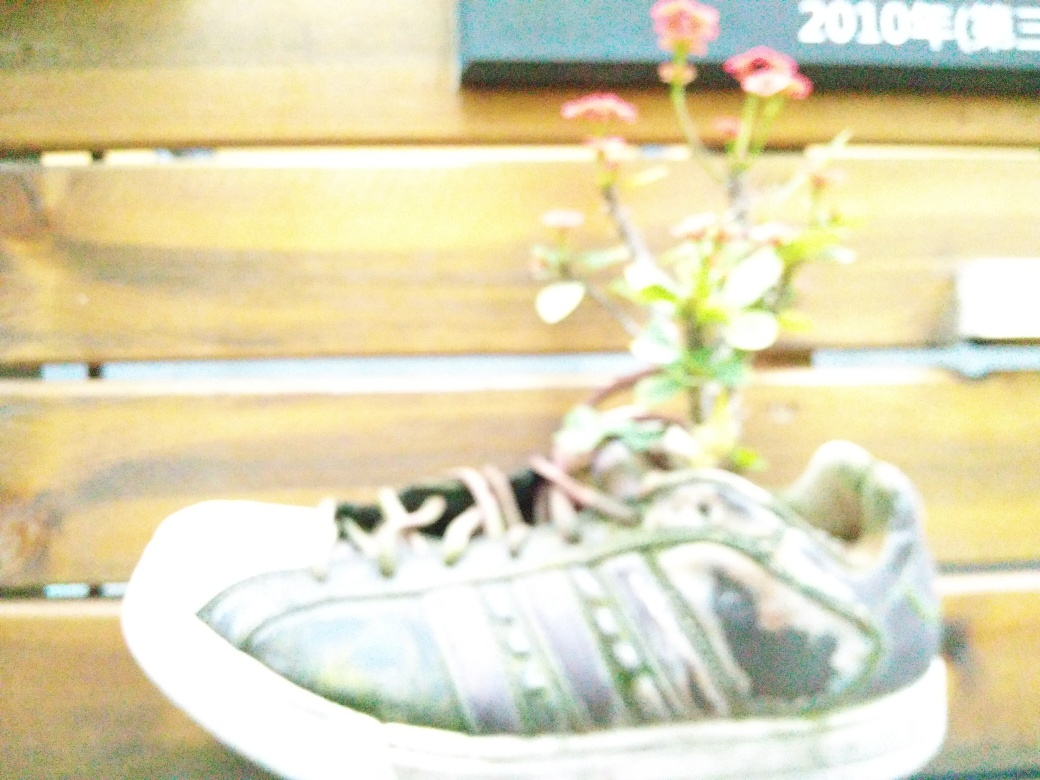What kind of plant would be best suited for growing in a shoe, considering the space and material? Small, hardy plants that require minimal soil and are tolerant of limited space would be best suited for growing in a shoe. Succulents or small flowering plants like the one in the image, which have adaptable root systems and don't require extensive water or nutrients, would thrive in such a compact environment. The choice of plant often depends on the shoe's material, which should allow for some drainage and breathability. 